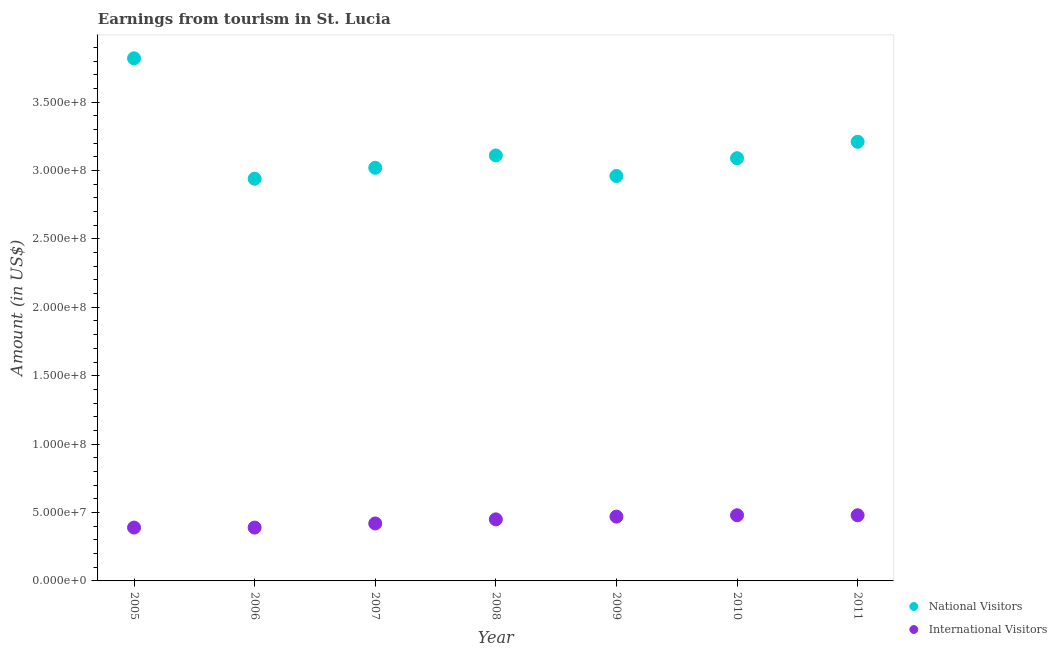How many different coloured dotlines are there?
Provide a short and direct response. 2. Is the number of dotlines equal to the number of legend labels?
Make the answer very short. Yes. What is the amount earned from national visitors in 2008?
Offer a terse response. 3.11e+08. Across all years, what is the maximum amount earned from international visitors?
Offer a very short reply. 4.80e+07. Across all years, what is the minimum amount earned from national visitors?
Give a very brief answer. 2.94e+08. What is the total amount earned from international visitors in the graph?
Provide a short and direct response. 3.08e+08. What is the difference between the amount earned from international visitors in 2005 and that in 2008?
Your answer should be very brief. -6.00e+06. What is the difference between the amount earned from international visitors in 2010 and the amount earned from national visitors in 2009?
Ensure brevity in your answer.  -2.48e+08. What is the average amount earned from national visitors per year?
Your answer should be very brief. 3.16e+08. In the year 2008, what is the difference between the amount earned from international visitors and amount earned from national visitors?
Provide a short and direct response. -2.66e+08. In how many years, is the amount earned from international visitors greater than 300000000 US$?
Keep it short and to the point. 0. What is the ratio of the amount earned from international visitors in 2007 to that in 2008?
Give a very brief answer. 0.93. What is the difference between the highest and the second highest amount earned from international visitors?
Your answer should be compact. 0. What is the difference between the highest and the lowest amount earned from international visitors?
Provide a short and direct response. 9.00e+06. Does the amount earned from international visitors monotonically increase over the years?
Ensure brevity in your answer.  No. How many dotlines are there?
Offer a very short reply. 2. Are the values on the major ticks of Y-axis written in scientific E-notation?
Your answer should be very brief. Yes. Does the graph contain grids?
Make the answer very short. No. Where does the legend appear in the graph?
Offer a very short reply. Bottom right. How many legend labels are there?
Your answer should be very brief. 2. What is the title of the graph?
Offer a very short reply. Earnings from tourism in St. Lucia. Does "Number of departures" appear as one of the legend labels in the graph?
Give a very brief answer. No. What is the label or title of the X-axis?
Your answer should be compact. Year. What is the Amount (in US$) of National Visitors in 2005?
Keep it short and to the point. 3.82e+08. What is the Amount (in US$) in International Visitors in 2005?
Provide a short and direct response. 3.90e+07. What is the Amount (in US$) in National Visitors in 2006?
Your answer should be very brief. 2.94e+08. What is the Amount (in US$) in International Visitors in 2006?
Your answer should be compact. 3.90e+07. What is the Amount (in US$) of National Visitors in 2007?
Keep it short and to the point. 3.02e+08. What is the Amount (in US$) in International Visitors in 2007?
Ensure brevity in your answer.  4.20e+07. What is the Amount (in US$) of National Visitors in 2008?
Provide a succinct answer. 3.11e+08. What is the Amount (in US$) of International Visitors in 2008?
Give a very brief answer. 4.50e+07. What is the Amount (in US$) of National Visitors in 2009?
Give a very brief answer. 2.96e+08. What is the Amount (in US$) of International Visitors in 2009?
Provide a short and direct response. 4.70e+07. What is the Amount (in US$) in National Visitors in 2010?
Provide a succinct answer. 3.09e+08. What is the Amount (in US$) in International Visitors in 2010?
Your response must be concise. 4.80e+07. What is the Amount (in US$) in National Visitors in 2011?
Offer a very short reply. 3.21e+08. What is the Amount (in US$) of International Visitors in 2011?
Provide a short and direct response. 4.80e+07. Across all years, what is the maximum Amount (in US$) in National Visitors?
Your answer should be compact. 3.82e+08. Across all years, what is the maximum Amount (in US$) in International Visitors?
Your response must be concise. 4.80e+07. Across all years, what is the minimum Amount (in US$) in National Visitors?
Provide a short and direct response. 2.94e+08. Across all years, what is the minimum Amount (in US$) in International Visitors?
Your response must be concise. 3.90e+07. What is the total Amount (in US$) in National Visitors in the graph?
Your answer should be very brief. 2.22e+09. What is the total Amount (in US$) in International Visitors in the graph?
Provide a succinct answer. 3.08e+08. What is the difference between the Amount (in US$) in National Visitors in 2005 and that in 2006?
Your answer should be compact. 8.80e+07. What is the difference between the Amount (in US$) of International Visitors in 2005 and that in 2006?
Give a very brief answer. 0. What is the difference between the Amount (in US$) in National Visitors in 2005 and that in 2007?
Your answer should be compact. 8.00e+07. What is the difference between the Amount (in US$) of International Visitors in 2005 and that in 2007?
Your response must be concise. -3.00e+06. What is the difference between the Amount (in US$) of National Visitors in 2005 and that in 2008?
Provide a short and direct response. 7.10e+07. What is the difference between the Amount (in US$) in International Visitors in 2005 and that in 2008?
Your answer should be compact. -6.00e+06. What is the difference between the Amount (in US$) in National Visitors in 2005 and that in 2009?
Your response must be concise. 8.60e+07. What is the difference between the Amount (in US$) of International Visitors in 2005 and that in 2009?
Ensure brevity in your answer.  -8.00e+06. What is the difference between the Amount (in US$) in National Visitors in 2005 and that in 2010?
Your answer should be very brief. 7.30e+07. What is the difference between the Amount (in US$) of International Visitors in 2005 and that in 2010?
Your answer should be very brief. -9.00e+06. What is the difference between the Amount (in US$) in National Visitors in 2005 and that in 2011?
Give a very brief answer. 6.10e+07. What is the difference between the Amount (in US$) of International Visitors in 2005 and that in 2011?
Offer a terse response. -9.00e+06. What is the difference between the Amount (in US$) in National Visitors in 2006 and that in 2007?
Offer a terse response. -8.00e+06. What is the difference between the Amount (in US$) in National Visitors in 2006 and that in 2008?
Give a very brief answer. -1.70e+07. What is the difference between the Amount (in US$) in International Visitors in 2006 and that in 2008?
Keep it short and to the point. -6.00e+06. What is the difference between the Amount (in US$) of National Visitors in 2006 and that in 2009?
Provide a short and direct response. -2.00e+06. What is the difference between the Amount (in US$) of International Visitors in 2006 and that in 2009?
Keep it short and to the point. -8.00e+06. What is the difference between the Amount (in US$) in National Visitors in 2006 and that in 2010?
Keep it short and to the point. -1.50e+07. What is the difference between the Amount (in US$) in International Visitors in 2006 and that in 2010?
Your answer should be compact. -9.00e+06. What is the difference between the Amount (in US$) of National Visitors in 2006 and that in 2011?
Give a very brief answer. -2.70e+07. What is the difference between the Amount (in US$) in International Visitors in 2006 and that in 2011?
Your answer should be very brief. -9.00e+06. What is the difference between the Amount (in US$) in National Visitors in 2007 and that in 2008?
Keep it short and to the point. -9.00e+06. What is the difference between the Amount (in US$) in National Visitors in 2007 and that in 2009?
Offer a very short reply. 6.00e+06. What is the difference between the Amount (in US$) of International Visitors in 2007 and that in 2009?
Make the answer very short. -5.00e+06. What is the difference between the Amount (in US$) in National Visitors in 2007 and that in 2010?
Keep it short and to the point. -7.00e+06. What is the difference between the Amount (in US$) of International Visitors in 2007 and that in 2010?
Give a very brief answer. -6.00e+06. What is the difference between the Amount (in US$) of National Visitors in 2007 and that in 2011?
Your answer should be very brief. -1.90e+07. What is the difference between the Amount (in US$) of International Visitors in 2007 and that in 2011?
Your answer should be compact. -6.00e+06. What is the difference between the Amount (in US$) in National Visitors in 2008 and that in 2009?
Keep it short and to the point. 1.50e+07. What is the difference between the Amount (in US$) in International Visitors in 2008 and that in 2009?
Give a very brief answer. -2.00e+06. What is the difference between the Amount (in US$) of National Visitors in 2008 and that in 2010?
Keep it short and to the point. 2.00e+06. What is the difference between the Amount (in US$) of National Visitors in 2008 and that in 2011?
Keep it short and to the point. -1.00e+07. What is the difference between the Amount (in US$) of National Visitors in 2009 and that in 2010?
Keep it short and to the point. -1.30e+07. What is the difference between the Amount (in US$) in International Visitors in 2009 and that in 2010?
Give a very brief answer. -1.00e+06. What is the difference between the Amount (in US$) in National Visitors in 2009 and that in 2011?
Keep it short and to the point. -2.50e+07. What is the difference between the Amount (in US$) in International Visitors in 2009 and that in 2011?
Provide a succinct answer. -1.00e+06. What is the difference between the Amount (in US$) in National Visitors in 2010 and that in 2011?
Make the answer very short. -1.20e+07. What is the difference between the Amount (in US$) in National Visitors in 2005 and the Amount (in US$) in International Visitors in 2006?
Provide a short and direct response. 3.43e+08. What is the difference between the Amount (in US$) in National Visitors in 2005 and the Amount (in US$) in International Visitors in 2007?
Ensure brevity in your answer.  3.40e+08. What is the difference between the Amount (in US$) of National Visitors in 2005 and the Amount (in US$) of International Visitors in 2008?
Offer a terse response. 3.37e+08. What is the difference between the Amount (in US$) of National Visitors in 2005 and the Amount (in US$) of International Visitors in 2009?
Your answer should be compact. 3.35e+08. What is the difference between the Amount (in US$) of National Visitors in 2005 and the Amount (in US$) of International Visitors in 2010?
Offer a very short reply. 3.34e+08. What is the difference between the Amount (in US$) of National Visitors in 2005 and the Amount (in US$) of International Visitors in 2011?
Keep it short and to the point. 3.34e+08. What is the difference between the Amount (in US$) of National Visitors in 2006 and the Amount (in US$) of International Visitors in 2007?
Provide a succinct answer. 2.52e+08. What is the difference between the Amount (in US$) of National Visitors in 2006 and the Amount (in US$) of International Visitors in 2008?
Give a very brief answer. 2.49e+08. What is the difference between the Amount (in US$) in National Visitors in 2006 and the Amount (in US$) in International Visitors in 2009?
Offer a terse response. 2.47e+08. What is the difference between the Amount (in US$) in National Visitors in 2006 and the Amount (in US$) in International Visitors in 2010?
Offer a terse response. 2.46e+08. What is the difference between the Amount (in US$) in National Visitors in 2006 and the Amount (in US$) in International Visitors in 2011?
Your answer should be very brief. 2.46e+08. What is the difference between the Amount (in US$) in National Visitors in 2007 and the Amount (in US$) in International Visitors in 2008?
Provide a short and direct response. 2.57e+08. What is the difference between the Amount (in US$) of National Visitors in 2007 and the Amount (in US$) of International Visitors in 2009?
Offer a terse response. 2.55e+08. What is the difference between the Amount (in US$) in National Visitors in 2007 and the Amount (in US$) in International Visitors in 2010?
Ensure brevity in your answer.  2.54e+08. What is the difference between the Amount (in US$) in National Visitors in 2007 and the Amount (in US$) in International Visitors in 2011?
Your answer should be very brief. 2.54e+08. What is the difference between the Amount (in US$) of National Visitors in 2008 and the Amount (in US$) of International Visitors in 2009?
Give a very brief answer. 2.64e+08. What is the difference between the Amount (in US$) in National Visitors in 2008 and the Amount (in US$) in International Visitors in 2010?
Provide a succinct answer. 2.63e+08. What is the difference between the Amount (in US$) of National Visitors in 2008 and the Amount (in US$) of International Visitors in 2011?
Your answer should be compact. 2.63e+08. What is the difference between the Amount (in US$) of National Visitors in 2009 and the Amount (in US$) of International Visitors in 2010?
Give a very brief answer. 2.48e+08. What is the difference between the Amount (in US$) of National Visitors in 2009 and the Amount (in US$) of International Visitors in 2011?
Keep it short and to the point. 2.48e+08. What is the difference between the Amount (in US$) in National Visitors in 2010 and the Amount (in US$) in International Visitors in 2011?
Ensure brevity in your answer.  2.61e+08. What is the average Amount (in US$) of National Visitors per year?
Give a very brief answer. 3.16e+08. What is the average Amount (in US$) of International Visitors per year?
Offer a very short reply. 4.40e+07. In the year 2005, what is the difference between the Amount (in US$) in National Visitors and Amount (in US$) in International Visitors?
Keep it short and to the point. 3.43e+08. In the year 2006, what is the difference between the Amount (in US$) of National Visitors and Amount (in US$) of International Visitors?
Keep it short and to the point. 2.55e+08. In the year 2007, what is the difference between the Amount (in US$) in National Visitors and Amount (in US$) in International Visitors?
Your answer should be very brief. 2.60e+08. In the year 2008, what is the difference between the Amount (in US$) in National Visitors and Amount (in US$) in International Visitors?
Provide a short and direct response. 2.66e+08. In the year 2009, what is the difference between the Amount (in US$) of National Visitors and Amount (in US$) of International Visitors?
Keep it short and to the point. 2.49e+08. In the year 2010, what is the difference between the Amount (in US$) of National Visitors and Amount (in US$) of International Visitors?
Provide a succinct answer. 2.61e+08. In the year 2011, what is the difference between the Amount (in US$) in National Visitors and Amount (in US$) in International Visitors?
Offer a terse response. 2.73e+08. What is the ratio of the Amount (in US$) in National Visitors in 2005 to that in 2006?
Offer a very short reply. 1.3. What is the ratio of the Amount (in US$) of International Visitors in 2005 to that in 2006?
Provide a short and direct response. 1. What is the ratio of the Amount (in US$) of National Visitors in 2005 to that in 2007?
Provide a succinct answer. 1.26. What is the ratio of the Amount (in US$) of National Visitors in 2005 to that in 2008?
Offer a terse response. 1.23. What is the ratio of the Amount (in US$) in International Visitors in 2005 to that in 2008?
Provide a succinct answer. 0.87. What is the ratio of the Amount (in US$) in National Visitors in 2005 to that in 2009?
Offer a very short reply. 1.29. What is the ratio of the Amount (in US$) of International Visitors in 2005 to that in 2009?
Keep it short and to the point. 0.83. What is the ratio of the Amount (in US$) in National Visitors in 2005 to that in 2010?
Make the answer very short. 1.24. What is the ratio of the Amount (in US$) of International Visitors in 2005 to that in 2010?
Provide a short and direct response. 0.81. What is the ratio of the Amount (in US$) of National Visitors in 2005 to that in 2011?
Provide a succinct answer. 1.19. What is the ratio of the Amount (in US$) of International Visitors in 2005 to that in 2011?
Your answer should be very brief. 0.81. What is the ratio of the Amount (in US$) in National Visitors in 2006 to that in 2007?
Your response must be concise. 0.97. What is the ratio of the Amount (in US$) in International Visitors in 2006 to that in 2007?
Make the answer very short. 0.93. What is the ratio of the Amount (in US$) of National Visitors in 2006 to that in 2008?
Provide a short and direct response. 0.95. What is the ratio of the Amount (in US$) of International Visitors in 2006 to that in 2008?
Your answer should be very brief. 0.87. What is the ratio of the Amount (in US$) of International Visitors in 2006 to that in 2009?
Provide a short and direct response. 0.83. What is the ratio of the Amount (in US$) of National Visitors in 2006 to that in 2010?
Offer a terse response. 0.95. What is the ratio of the Amount (in US$) of International Visitors in 2006 to that in 2010?
Your answer should be very brief. 0.81. What is the ratio of the Amount (in US$) of National Visitors in 2006 to that in 2011?
Your response must be concise. 0.92. What is the ratio of the Amount (in US$) of International Visitors in 2006 to that in 2011?
Your answer should be compact. 0.81. What is the ratio of the Amount (in US$) in National Visitors in 2007 to that in 2008?
Ensure brevity in your answer.  0.97. What is the ratio of the Amount (in US$) in National Visitors in 2007 to that in 2009?
Keep it short and to the point. 1.02. What is the ratio of the Amount (in US$) of International Visitors in 2007 to that in 2009?
Make the answer very short. 0.89. What is the ratio of the Amount (in US$) in National Visitors in 2007 to that in 2010?
Give a very brief answer. 0.98. What is the ratio of the Amount (in US$) of International Visitors in 2007 to that in 2010?
Keep it short and to the point. 0.88. What is the ratio of the Amount (in US$) of National Visitors in 2007 to that in 2011?
Ensure brevity in your answer.  0.94. What is the ratio of the Amount (in US$) in International Visitors in 2007 to that in 2011?
Provide a succinct answer. 0.88. What is the ratio of the Amount (in US$) in National Visitors in 2008 to that in 2009?
Provide a succinct answer. 1.05. What is the ratio of the Amount (in US$) of International Visitors in 2008 to that in 2009?
Give a very brief answer. 0.96. What is the ratio of the Amount (in US$) of International Visitors in 2008 to that in 2010?
Keep it short and to the point. 0.94. What is the ratio of the Amount (in US$) in National Visitors in 2008 to that in 2011?
Offer a very short reply. 0.97. What is the ratio of the Amount (in US$) of International Visitors in 2008 to that in 2011?
Make the answer very short. 0.94. What is the ratio of the Amount (in US$) in National Visitors in 2009 to that in 2010?
Offer a very short reply. 0.96. What is the ratio of the Amount (in US$) in International Visitors in 2009 to that in 2010?
Offer a very short reply. 0.98. What is the ratio of the Amount (in US$) in National Visitors in 2009 to that in 2011?
Provide a succinct answer. 0.92. What is the ratio of the Amount (in US$) of International Visitors in 2009 to that in 2011?
Keep it short and to the point. 0.98. What is the ratio of the Amount (in US$) in National Visitors in 2010 to that in 2011?
Ensure brevity in your answer.  0.96. What is the ratio of the Amount (in US$) of International Visitors in 2010 to that in 2011?
Keep it short and to the point. 1. What is the difference between the highest and the second highest Amount (in US$) of National Visitors?
Provide a short and direct response. 6.10e+07. What is the difference between the highest and the second highest Amount (in US$) in International Visitors?
Keep it short and to the point. 0. What is the difference between the highest and the lowest Amount (in US$) in National Visitors?
Give a very brief answer. 8.80e+07. What is the difference between the highest and the lowest Amount (in US$) of International Visitors?
Provide a short and direct response. 9.00e+06. 